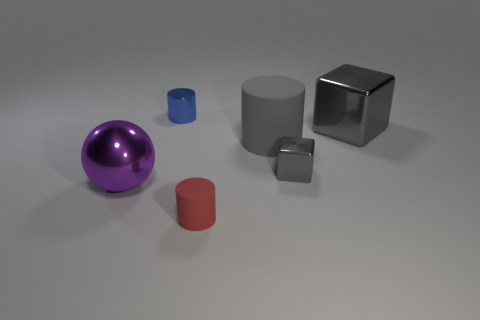Subtract all big matte cylinders. How many cylinders are left? 2 Subtract all red cylinders. How many cylinders are left? 2 Add 1 tiny blue cubes. How many objects exist? 7 Subtract all spheres. How many objects are left? 5 Subtract all matte things. Subtract all large metallic cubes. How many objects are left? 3 Add 6 balls. How many balls are left? 7 Add 1 tiny blue things. How many tiny blue things exist? 2 Subtract 0 cyan cubes. How many objects are left? 6 Subtract all green blocks. Subtract all red cylinders. How many blocks are left? 2 